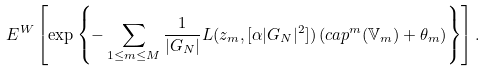Convert formula to latex. <formula><loc_0><loc_0><loc_500><loc_500>E ^ { W } \left [ \exp \left \{ - \sum _ { 1 \leq m \leq M } \frac { 1 } { | G _ { N } | } L ( z _ { m } , [ \alpha | G _ { N } | ^ { 2 } ] ) \left ( c a p ^ { m } ( { \mathbb { V } } _ { m } ) + \theta _ { m } \right ) \right \} \right ] .</formula> 